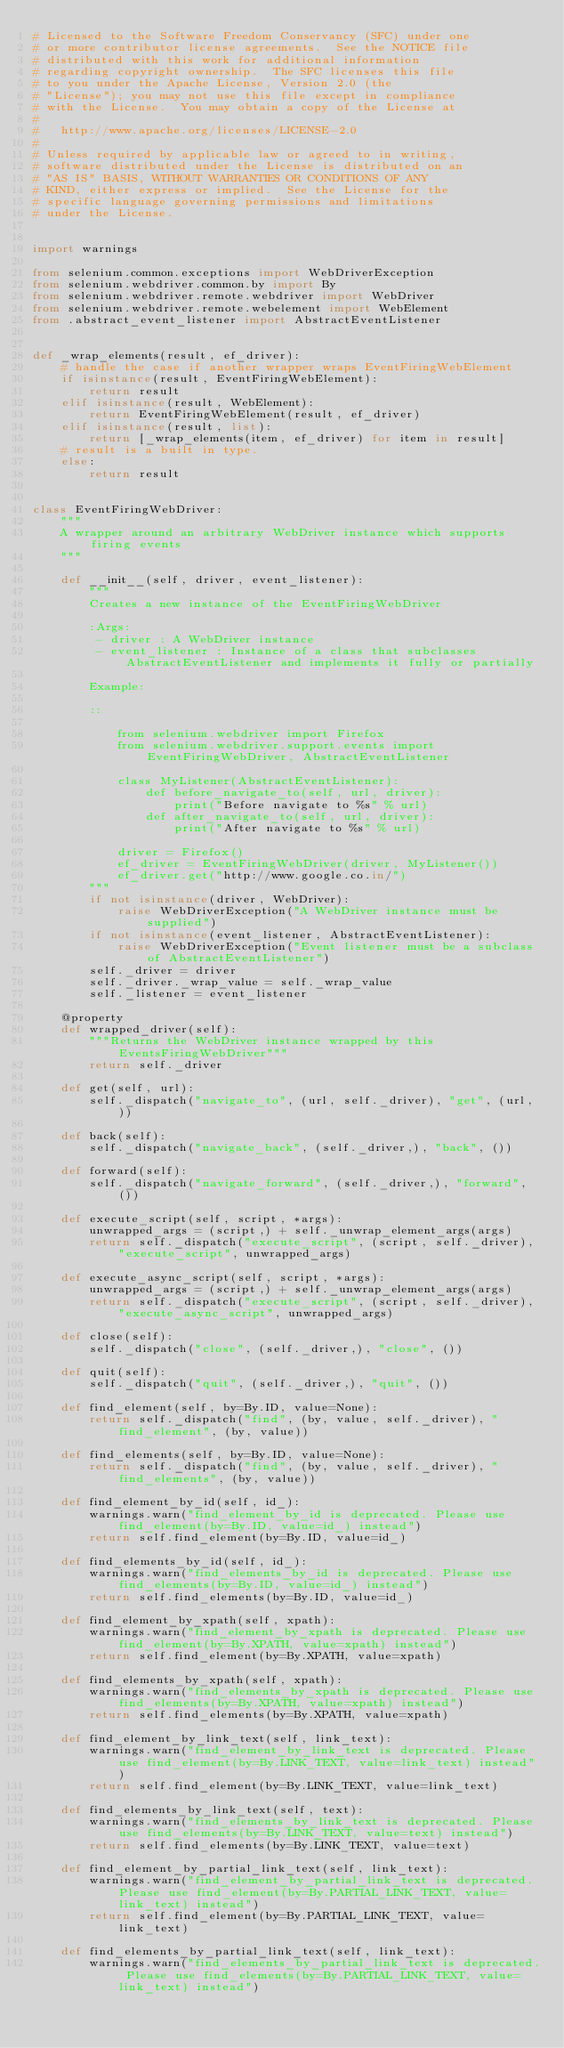Convert code to text. <code><loc_0><loc_0><loc_500><loc_500><_Python_># Licensed to the Software Freedom Conservancy (SFC) under one
# or more contributor license agreements.  See the NOTICE file
# distributed with this work for additional information
# regarding copyright ownership.  The SFC licenses this file
# to you under the Apache License, Version 2.0 (the
# "License"); you may not use this file except in compliance
# with the License.  You may obtain a copy of the License at
#
#   http://www.apache.org/licenses/LICENSE-2.0
#
# Unless required by applicable law or agreed to in writing,
# software distributed under the License is distributed on an
# "AS IS" BASIS, WITHOUT WARRANTIES OR CONDITIONS OF ANY
# KIND, either express or implied.  See the License for the
# specific language governing permissions and limitations
# under the License.


import warnings

from selenium.common.exceptions import WebDriverException
from selenium.webdriver.common.by import By
from selenium.webdriver.remote.webdriver import WebDriver
from selenium.webdriver.remote.webelement import WebElement
from .abstract_event_listener import AbstractEventListener


def _wrap_elements(result, ef_driver):
    # handle the case if another wrapper wraps EventFiringWebElement
    if isinstance(result, EventFiringWebElement):
        return result
    elif isinstance(result, WebElement):
        return EventFiringWebElement(result, ef_driver)
    elif isinstance(result, list):
        return [_wrap_elements(item, ef_driver) for item in result]
    # result is a built in type.
    else:
        return result


class EventFiringWebDriver:
    """
    A wrapper around an arbitrary WebDriver instance which supports firing events
    """

    def __init__(self, driver, event_listener):
        """
        Creates a new instance of the EventFiringWebDriver

        :Args:
         - driver : A WebDriver instance
         - event_listener : Instance of a class that subclasses AbstractEventListener and implements it fully or partially

        Example:

        ::

            from selenium.webdriver import Firefox
            from selenium.webdriver.support.events import EventFiringWebDriver, AbstractEventListener

            class MyListener(AbstractEventListener):
                def before_navigate_to(self, url, driver):
                    print("Before navigate to %s" % url)
                def after_navigate_to(self, url, driver):
                    print("After navigate to %s" % url)

            driver = Firefox()
            ef_driver = EventFiringWebDriver(driver, MyListener())
            ef_driver.get("http://www.google.co.in/")
        """
        if not isinstance(driver, WebDriver):
            raise WebDriverException("A WebDriver instance must be supplied")
        if not isinstance(event_listener, AbstractEventListener):
            raise WebDriverException("Event listener must be a subclass of AbstractEventListener")
        self._driver = driver
        self._driver._wrap_value = self._wrap_value
        self._listener = event_listener

    @property
    def wrapped_driver(self):
        """Returns the WebDriver instance wrapped by this EventsFiringWebDriver"""
        return self._driver

    def get(self, url):
        self._dispatch("navigate_to", (url, self._driver), "get", (url, ))

    def back(self):
        self._dispatch("navigate_back", (self._driver,), "back", ())

    def forward(self):
        self._dispatch("navigate_forward", (self._driver,), "forward", ())

    def execute_script(self, script, *args):
        unwrapped_args = (script,) + self._unwrap_element_args(args)
        return self._dispatch("execute_script", (script, self._driver), "execute_script", unwrapped_args)

    def execute_async_script(self, script, *args):
        unwrapped_args = (script,) + self._unwrap_element_args(args)
        return self._dispatch("execute_script", (script, self._driver), "execute_async_script", unwrapped_args)

    def close(self):
        self._dispatch("close", (self._driver,), "close", ())

    def quit(self):
        self._dispatch("quit", (self._driver,), "quit", ())

    def find_element(self, by=By.ID, value=None):
        return self._dispatch("find", (by, value, self._driver), "find_element", (by, value))

    def find_elements(self, by=By.ID, value=None):
        return self._dispatch("find", (by, value, self._driver), "find_elements", (by, value))

    def find_element_by_id(self, id_):
        warnings.warn("find_element_by_id is deprecated. Please use find_element(by=By.ID, value=id_) instead")
        return self.find_element(by=By.ID, value=id_)

    def find_elements_by_id(self, id_):
        warnings.warn("find_elements_by_id is deprecated. Please use find_elements(by=By.ID, value=id_) instead")
        return self.find_elements(by=By.ID, value=id_)

    def find_element_by_xpath(self, xpath):
        warnings.warn("find_element_by_xpath is deprecated. Please use find_element(by=By.XPATH, value=xpath) instead")
        return self.find_element(by=By.XPATH, value=xpath)

    def find_elements_by_xpath(self, xpath):
        warnings.warn("find_elements_by_xpath is deprecated. Please use find_elements(by=By.XPATH, value=xpath) instead")
        return self.find_elements(by=By.XPATH, value=xpath)

    def find_element_by_link_text(self, link_text):
        warnings.warn("find_element_by_link_text is deprecated. Please use find_element(by=By.LINK_TEXT, value=link_text) instead")
        return self.find_element(by=By.LINK_TEXT, value=link_text)

    def find_elements_by_link_text(self, text):
        warnings.warn("find_elements_by_link_text is deprecated. Please use find_elements(by=By.LINK_TEXT, value=text) instead")
        return self.find_elements(by=By.LINK_TEXT, value=text)

    def find_element_by_partial_link_text(self, link_text):
        warnings.warn("find_element_by_partial_link_text is deprecated. Please use find_element(by=By.PARTIAL_LINK_TEXT, value=link_text) instead")
        return self.find_element(by=By.PARTIAL_LINK_TEXT, value=link_text)

    def find_elements_by_partial_link_text(self, link_text):
        warnings.warn("find_elements_by_partial_link_text is deprecated. Please use find_elements(by=By.PARTIAL_LINK_TEXT, value=link_text) instead")</code> 